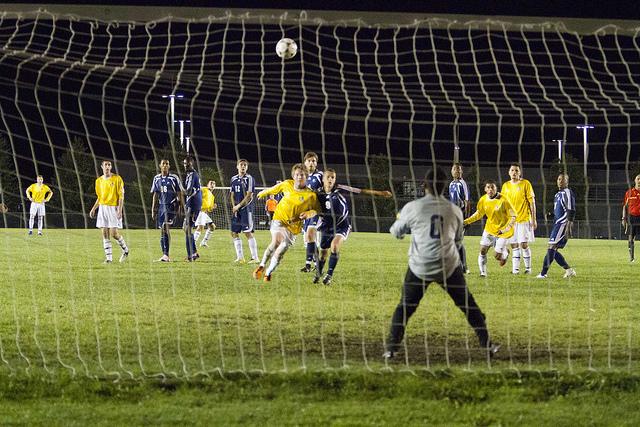What color is the goalie's shirt?
Give a very brief answer. Gray. Does it appear that the ball will make it into the goal?
Be succinct. Yes. What sport is this?
Answer briefly. Soccer. How many out of fifteen people are wearing yellow?
Give a very brief answer. 6. 